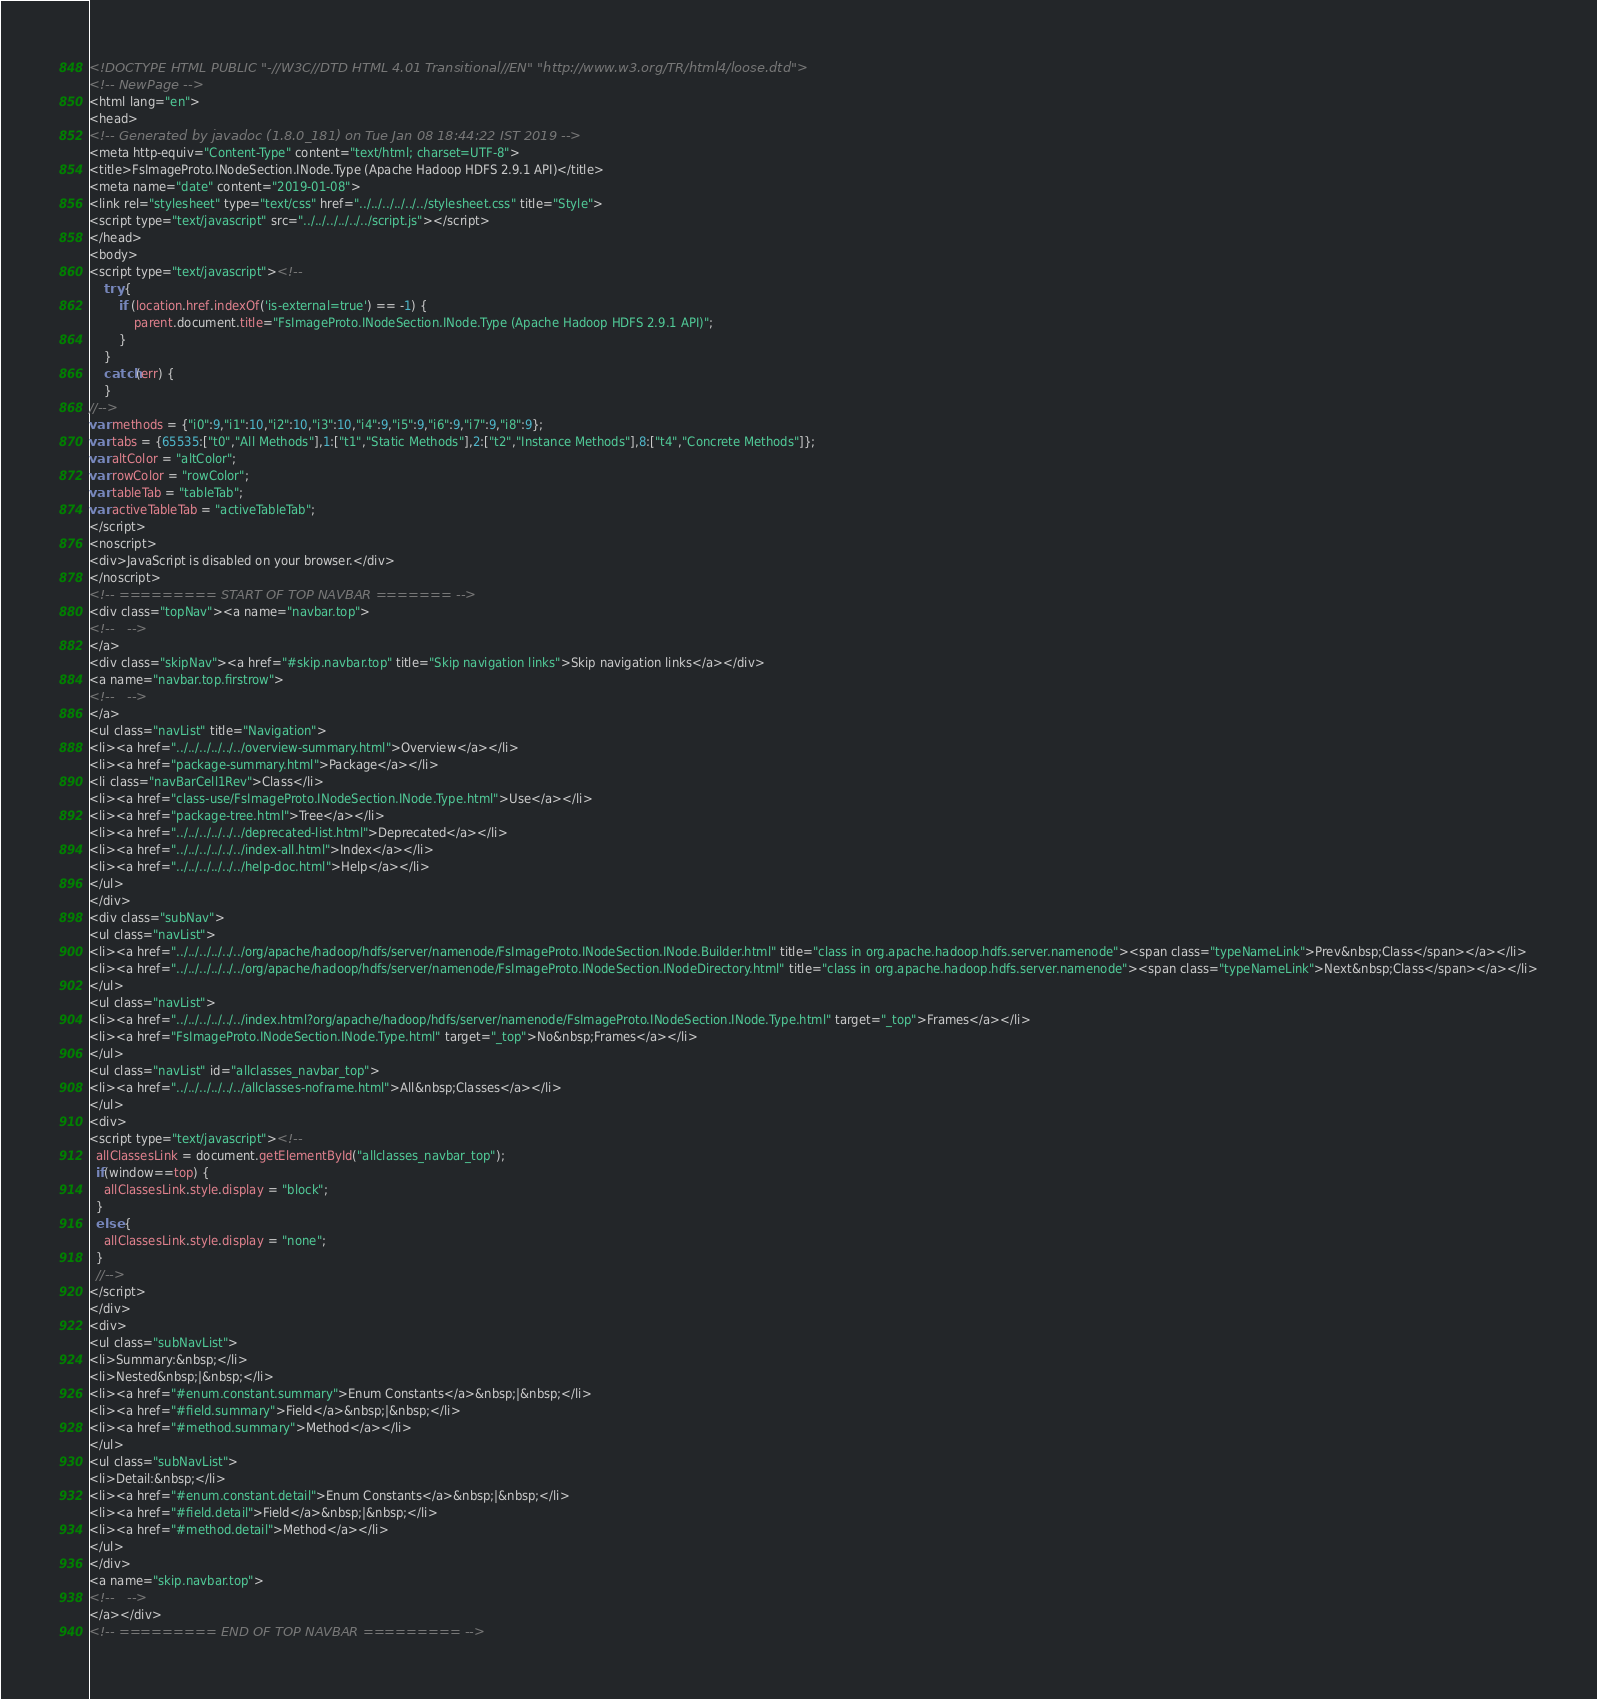<code> <loc_0><loc_0><loc_500><loc_500><_HTML_><!DOCTYPE HTML PUBLIC "-//W3C//DTD HTML 4.01 Transitional//EN" "http://www.w3.org/TR/html4/loose.dtd">
<!-- NewPage -->
<html lang="en">
<head>
<!-- Generated by javadoc (1.8.0_181) on Tue Jan 08 18:44:22 IST 2019 -->
<meta http-equiv="Content-Type" content="text/html; charset=UTF-8">
<title>FsImageProto.INodeSection.INode.Type (Apache Hadoop HDFS 2.9.1 API)</title>
<meta name="date" content="2019-01-08">
<link rel="stylesheet" type="text/css" href="../../../../../../stylesheet.css" title="Style">
<script type="text/javascript" src="../../../../../../script.js"></script>
</head>
<body>
<script type="text/javascript"><!--
    try {
        if (location.href.indexOf('is-external=true') == -1) {
            parent.document.title="FsImageProto.INodeSection.INode.Type (Apache Hadoop HDFS 2.9.1 API)";
        }
    }
    catch(err) {
    }
//-->
var methods = {"i0":9,"i1":10,"i2":10,"i3":10,"i4":9,"i5":9,"i6":9,"i7":9,"i8":9};
var tabs = {65535:["t0","All Methods"],1:["t1","Static Methods"],2:["t2","Instance Methods"],8:["t4","Concrete Methods"]};
var altColor = "altColor";
var rowColor = "rowColor";
var tableTab = "tableTab";
var activeTableTab = "activeTableTab";
</script>
<noscript>
<div>JavaScript is disabled on your browser.</div>
</noscript>
<!-- ========= START OF TOP NAVBAR ======= -->
<div class="topNav"><a name="navbar.top">
<!--   -->
</a>
<div class="skipNav"><a href="#skip.navbar.top" title="Skip navigation links">Skip navigation links</a></div>
<a name="navbar.top.firstrow">
<!--   -->
</a>
<ul class="navList" title="Navigation">
<li><a href="../../../../../../overview-summary.html">Overview</a></li>
<li><a href="package-summary.html">Package</a></li>
<li class="navBarCell1Rev">Class</li>
<li><a href="class-use/FsImageProto.INodeSection.INode.Type.html">Use</a></li>
<li><a href="package-tree.html">Tree</a></li>
<li><a href="../../../../../../deprecated-list.html">Deprecated</a></li>
<li><a href="../../../../../../index-all.html">Index</a></li>
<li><a href="../../../../../../help-doc.html">Help</a></li>
</ul>
</div>
<div class="subNav">
<ul class="navList">
<li><a href="../../../../../../org/apache/hadoop/hdfs/server/namenode/FsImageProto.INodeSection.INode.Builder.html" title="class in org.apache.hadoop.hdfs.server.namenode"><span class="typeNameLink">Prev&nbsp;Class</span></a></li>
<li><a href="../../../../../../org/apache/hadoop/hdfs/server/namenode/FsImageProto.INodeSection.INodeDirectory.html" title="class in org.apache.hadoop.hdfs.server.namenode"><span class="typeNameLink">Next&nbsp;Class</span></a></li>
</ul>
<ul class="navList">
<li><a href="../../../../../../index.html?org/apache/hadoop/hdfs/server/namenode/FsImageProto.INodeSection.INode.Type.html" target="_top">Frames</a></li>
<li><a href="FsImageProto.INodeSection.INode.Type.html" target="_top">No&nbsp;Frames</a></li>
</ul>
<ul class="navList" id="allclasses_navbar_top">
<li><a href="../../../../../../allclasses-noframe.html">All&nbsp;Classes</a></li>
</ul>
<div>
<script type="text/javascript"><!--
  allClassesLink = document.getElementById("allclasses_navbar_top");
  if(window==top) {
    allClassesLink.style.display = "block";
  }
  else {
    allClassesLink.style.display = "none";
  }
  //-->
</script>
</div>
<div>
<ul class="subNavList">
<li>Summary:&nbsp;</li>
<li>Nested&nbsp;|&nbsp;</li>
<li><a href="#enum.constant.summary">Enum Constants</a>&nbsp;|&nbsp;</li>
<li><a href="#field.summary">Field</a>&nbsp;|&nbsp;</li>
<li><a href="#method.summary">Method</a></li>
</ul>
<ul class="subNavList">
<li>Detail:&nbsp;</li>
<li><a href="#enum.constant.detail">Enum Constants</a>&nbsp;|&nbsp;</li>
<li><a href="#field.detail">Field</a>&nbsp;|&nbsp;</li>
<li><a href="#method.detail">Method</a></li>
</ul>
</div>
<a name="skip.navbar.top">
<!--   -->
</a></div>
<!-- ========= END OF TOP NAVBAR ========= --></code> 